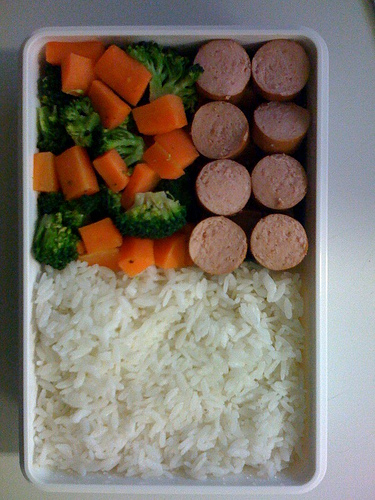<image>What color is the knife handle? There is no knife in the image. Where are the apples? The apples are not visible in the image. They could possibly be in the fridge or under the plate. What color is the knife handle? There is no knife in the image. Where are the apples? It is unclear where the apples are. They might be absent or nowhere to be found. 